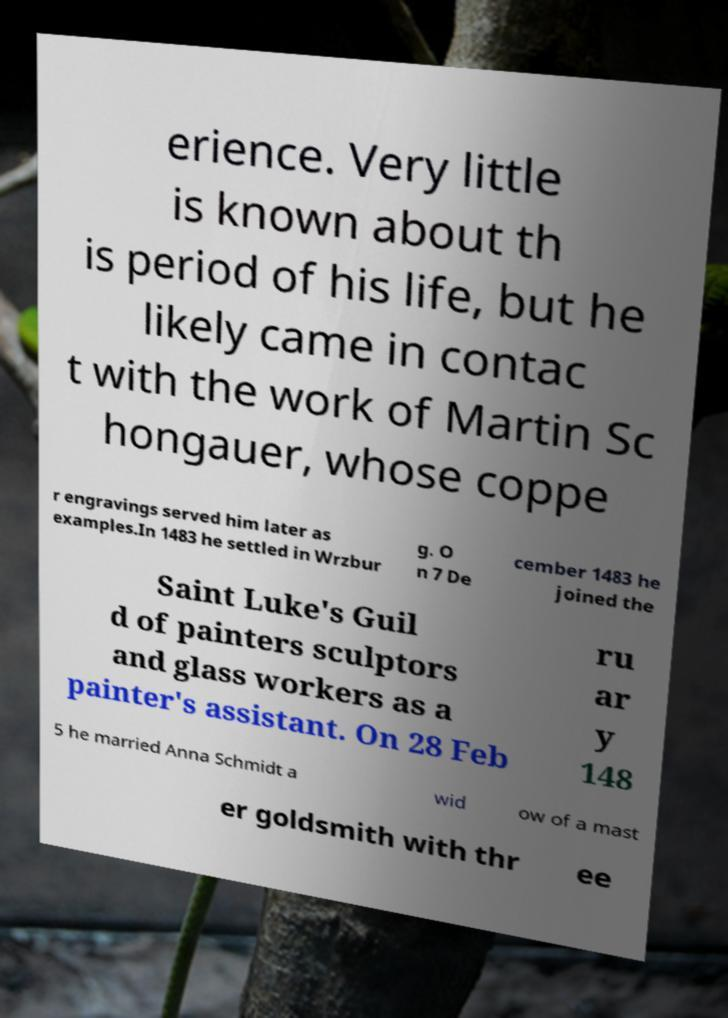Can you read and provide the text displayed in the image?This photo seems to have some interesting text. Can you extract and type it out for me? erience. Very little is known about th is period of his life, but he likely came in contac t with the work of Martin Sc hongauer, whose coppe r engravings served him later as examples.In 1483 he settled in Wrzbur g. O n 7 De cember 1483 he joined the Saint Luke's Guil d of painters sculptors and glass workers as a painter's assistant. On 28 Feb ru ar y 148 5 he married Anna Schmidt a wid ow of a mast er goldsmith with thr ee 